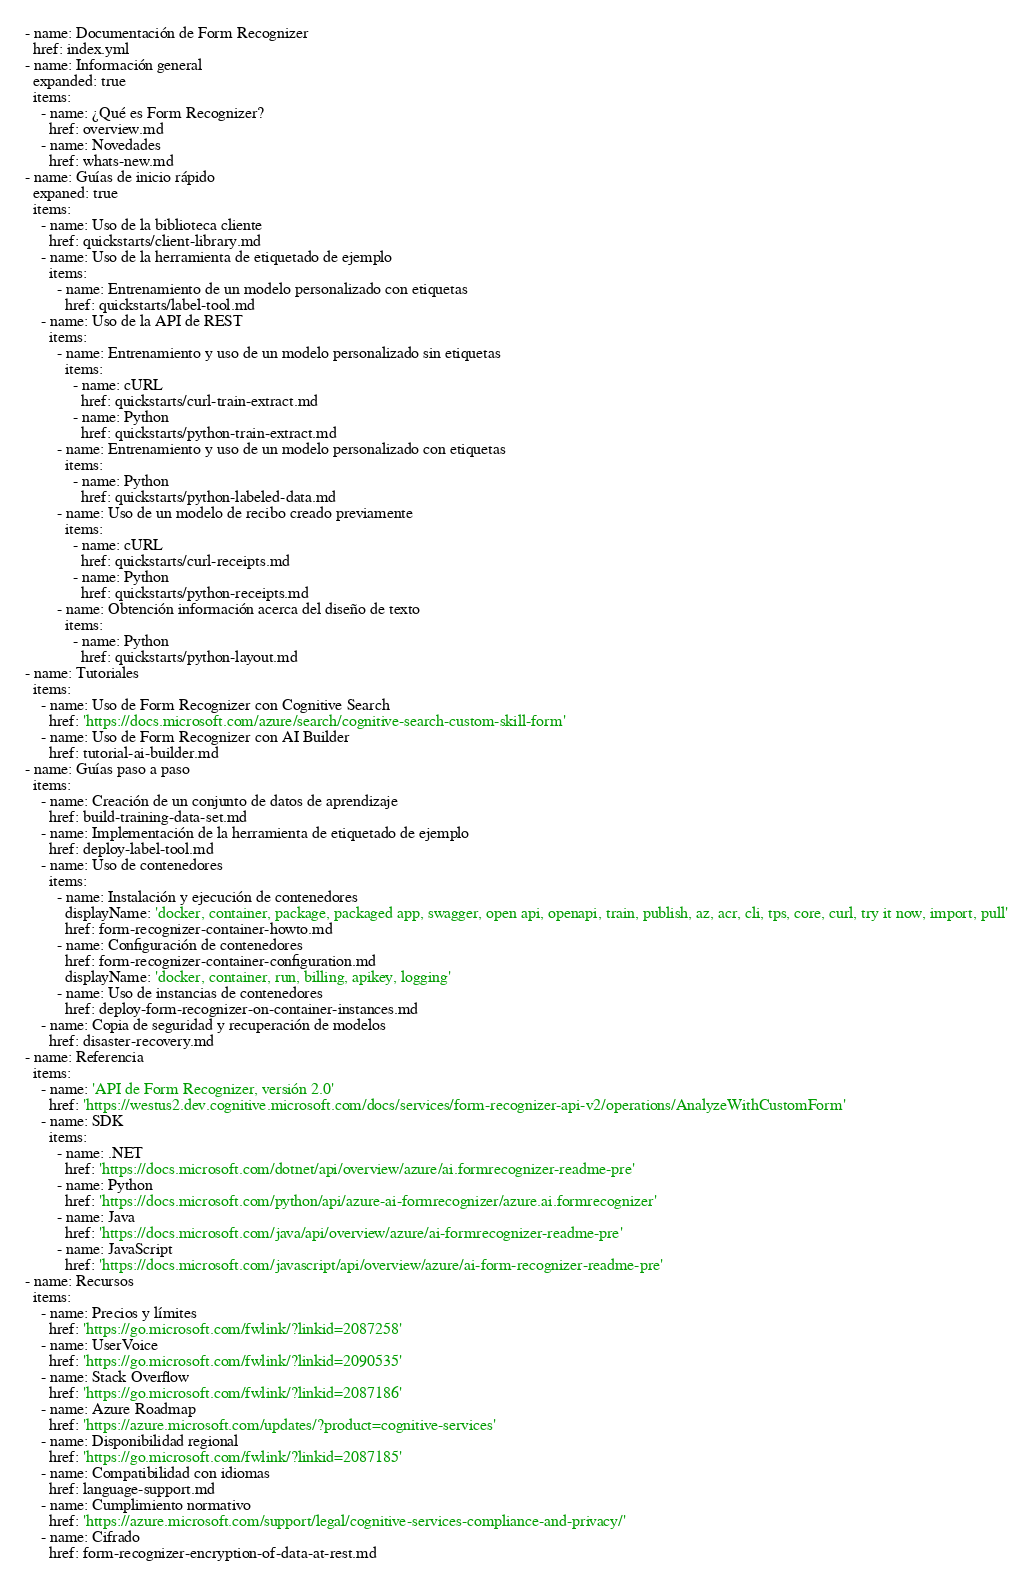Convert code to text. <code><loc_0><loc_0><loc_500><loc_500><_YAML_>- name: Documentación de Form Recognizer
  href: index.yml
- name: Información general
  expanded: true
  items:
    - name: ¿Qué es Form Recognizer?
      href: overview.md
    - name: Novedades
      href: whats-new.md
- name: Guías de inicio rápido
  expaned: true
  items:
    - name: Uso de la biblioteca cliente
      href: quickstarts/client-library.md
    - name: Uso de la herramienta de etiquetado de ejemplo
      items:
        - name: Entrenamiento de un modelo personalizado con etiquetas
          href: quickstarts/label-tool.md
    - name: Uso de la API de REST
      items:
        - name: Entrenamiento y uso de un modelo personalizado sin etiquetas
          items:
            - name: cURL
              href: quickstarts/curl-train-extract.md
            - name: Python
              href: quickstarts/python-train-extract.md
        - name: Entrenamiento y uso de un modelo personalizado con etiquetas
          items:
            - name: Python
              href: quickstarts/python-labeled-data.md
        - name: Uso de un modelo de recibo creado previamente
          items:
            - name: cURL
              href: quickstarts/curl-receipts.md
            - name: Python
              href: quickstarts/python-receipts.md
        - name: Obtención información acerca del diseño de texto
          items:
            - name: Python
              href: quickstarts/python-layout.md
- name: Tutoriales
  items:
    - name: Uso de Form Recognizer con Cognitive Search
      href: 'https://docs.microsoft.com/azure/search/cognitive-search-custom-skill-form'
    - name: Uso de Form Recognizer con AI Builder
      href: tutorial-ai-builder.md
- name: Guías paso a paso
  items:
    - name: Creación de un conjunto de datos de aprendizaje
      href: build-training-data-set.md
    - name: Implementación de la herramienta de etiquetado de ejemplo
      href: deploy-label-tool.md
    - name: Uso de contenedores
      items:
        - name: Instalación y ejecución de contenedores
          displayName: 'docker, container, package, packaged app, swagger, open api, openapi, train, publish, az, acr, cli, tps, core, curl, try it now, import, pull'
          href: form-recognizer-container-howto.md
        - name: Configuración de contenedores
          href: form-recognizer-container-configuration.md
          displayName: 'docker, container, run, billing, apikey, logging'
        - name: Uso de instancias de contenedores
          href: deploy-form-recognizer-on-container-instances.md
    - name: Copia de seguridad y recuperación de modelos
      href: disaster-recovery.md
- name: Referencia
  items:
    - name: 'API de Form Recognizer, versión 2.0'
      href: 'https://westus2.dev.cognitive.microsoft.com/docs/services/form-recognizer-api-v2/operations/AnalyzeWithCustomForm'
    - name: SDK
      items:
        - name: .NET
          href: 'https://docs.microsoft.com/dotnet/api/overview/azure/ai.formrecognizer-readme-pre'
        - name: Python
          href: 'https://docs.microsoft.com/python/api/azure-ai-formrecognizer/azure.ai.formrecognizer'
        - name: Java
          href: 'https://docs.microsoft.com/java/api/overview/azure/ai-formrecognizer-readme-pre'
        - name: JavaScript
          href: 'https://docs.microsoft.com/javascript/api/overview/azure/ai-form-recognizer-readme-pre'
- name: Recursos
  items:
    - name: Precios y límites
      href: 'https://go.microsoft.com/fwlink/?linkid=2087258'
    - name: UserVoice
      href: 'https://go.microsoft.com/fwlink/?linkid=2090535'
    - name: Stack Overflow
      href: 'https://go.microsoft.com/fwlink/?linkid=2087186'
    - name: Azure Roadmap
      href: 'https://azure.microsoft.com/updates/?product=cognitive-services'
    - name: Disponibilidad regional
      href: 'https://go.microsoft.com/fwlink/?linkid=2087185'
    - name: Compatibilidad con idiomas
      href: language-support.md
    - name: Cumplimiento normativo
      href: 'https://azure.microsoft.com/support/legal/cognitive-services-compliance-and-privacy/'
    - name: Cifrado
      href: form-recognizer-encryption-of-data-at-rest.md</code> 